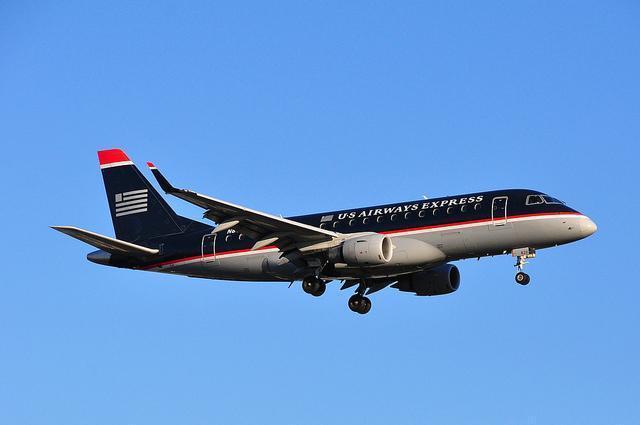How many clouds in the sky?
Give a very brief answer. 0. How many people in the image have on backpacks?
Give a very brief answer. 0. 